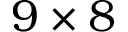<formula> <loc_0><loc_0><loc_500><loc_500>9 \times 8</formula> 